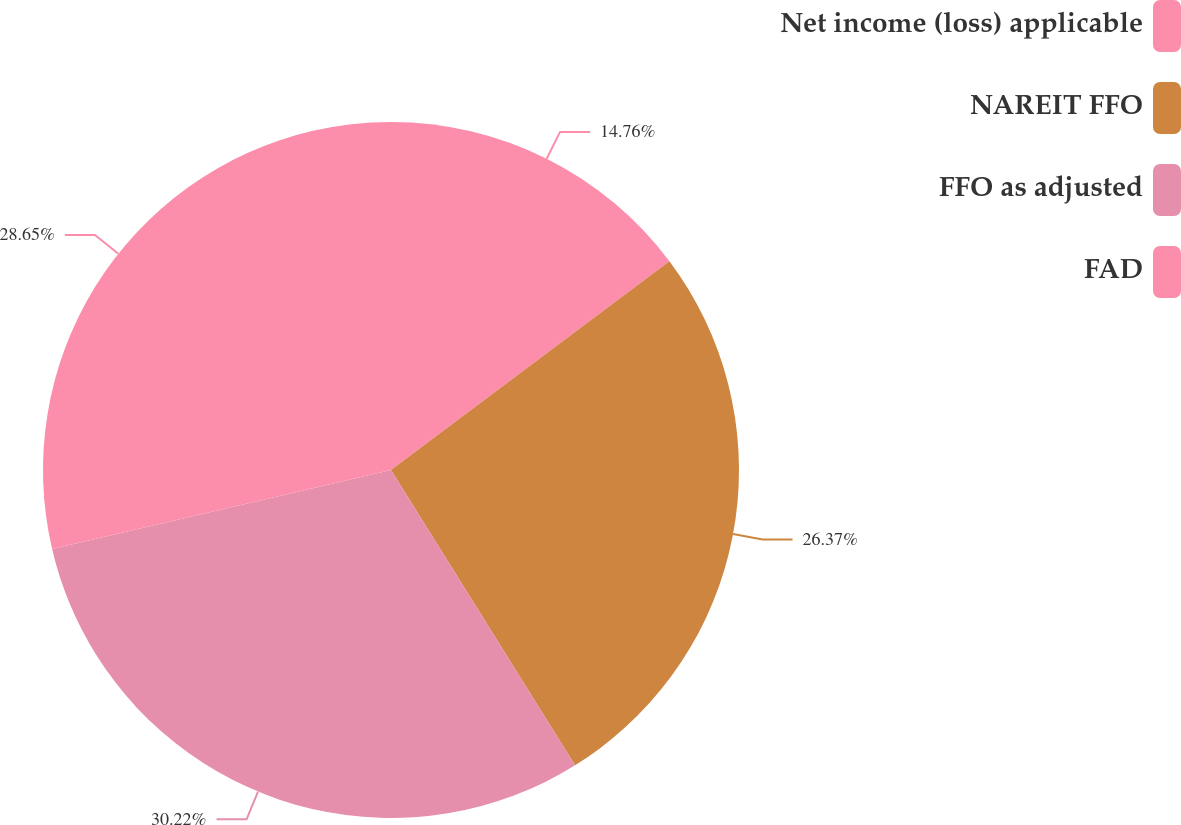<chart> <loc_0><loc_0><loc_500><loc_500><pie_chart><fcel>Net income (loss) applicable<fcel>NAREIT FFO<fcel>FFO as adjusted<fcel>FAD<nl><fcel>14.76%<fcel>26.37%<fcel>30.22%<fcel>28.65%<nl></chart> 